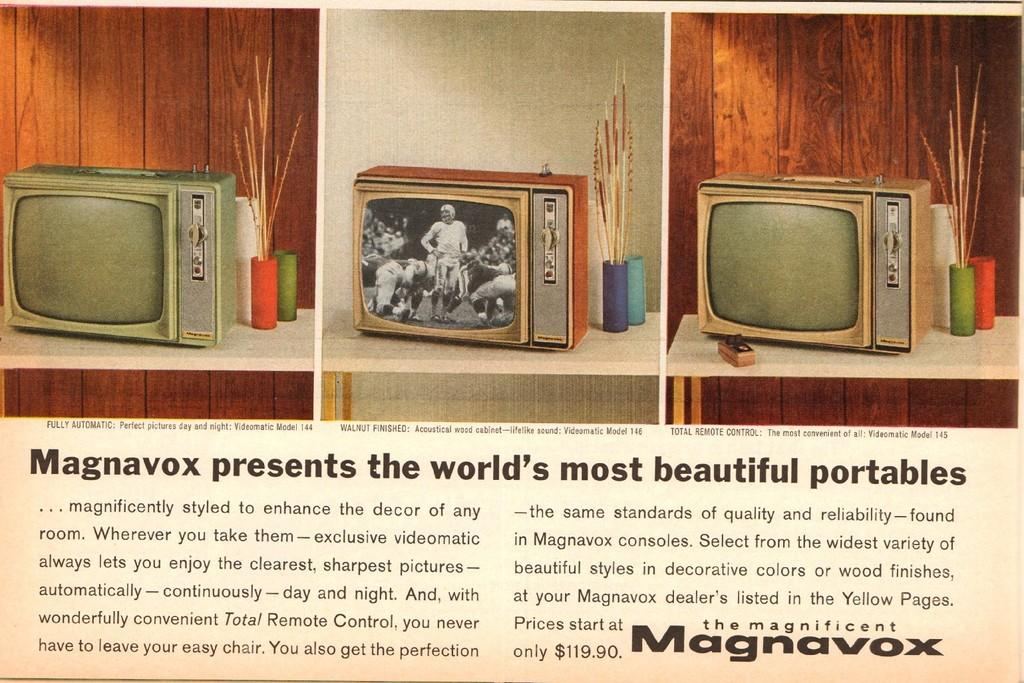<image>
Give a short and clear explanation of the subsequent image. a Magnavox ad that has a tv in it 